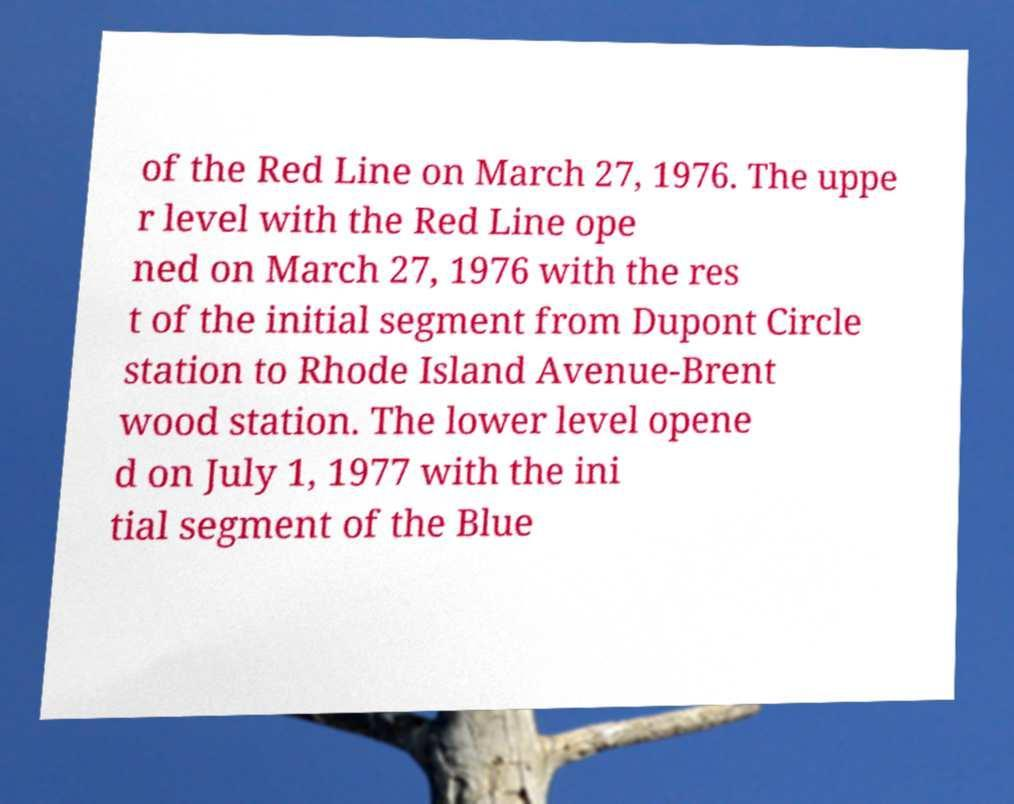What messages or text are displayed in this image? I need them in a readable, typed format. of the Red Line on March 27, 1976. The uppe r level with the Red Line ope ned on March 27, 1976 with the res t of the initial segment from Dupont Circle station to Rhode Island Avenue-Brent wood station. The lower level opene d on July 1, 1977 with the ini tial segment of the Blue 